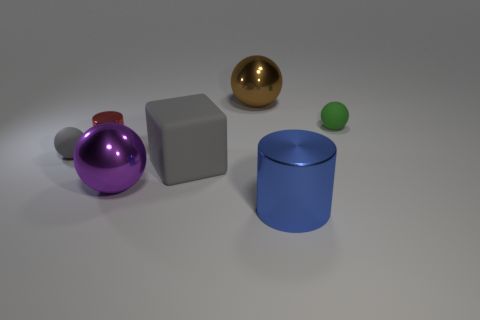There is a sphere that is behind the large gray cube and left of the large rubber cube; what is it made of?
Give a very brief answer. Rubber. There is a small metallic thing; is it the same shape as the large thing in front of the big purple shiny ball?
Keep it short and to the point. Yes. What number of objects are either large brown metal spheres or tiny things?
Give a very brief answer. 4. What is the shape of the metallic thing to the right of the big metallic ball that is right of the large gray thing?
Provide a succinct answer. Cylinder. There is a small thing behind the tiny shiny cylinder; is its shape the same as the blue thing?
Offer a very short reply. No. There is a red object that is made of the same material as the big purple object; what is its size?
Give a very brief answer. Small. What number of things are cylinders left of the large blue cylinder or matte objects that are behind the gray block?
Your response must be concise. 3. Are there an equal number of large gray rubber cubes to the left of the small red cylinder and small gray objects on the left side of the gray ball?
Provide a succinct answer. Yes. There is a metallic sphere behind the purple thing; what is its color?
Ensure brevity in your answer.  Brown. There is a large rubber object; is it the same color as the tiny ball to the left of the block?
Ensure brevity in your answer.  Yes. 